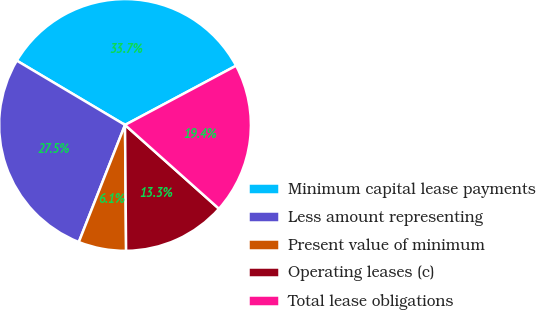<chart> <loc_0><loc_0><loc_500><loc_500><pie_chart><fcel>Minimum capital lease payments<fcel>Less amount representing<fcel>Present value of minimum<fcel>Operating leases (c)<fcel>Total lease obligations<nl><fcel>33.67%<fcel>27.55%<fcel>6.12%<fcel>13.27%<fcel>19.39%<nl></chart> 